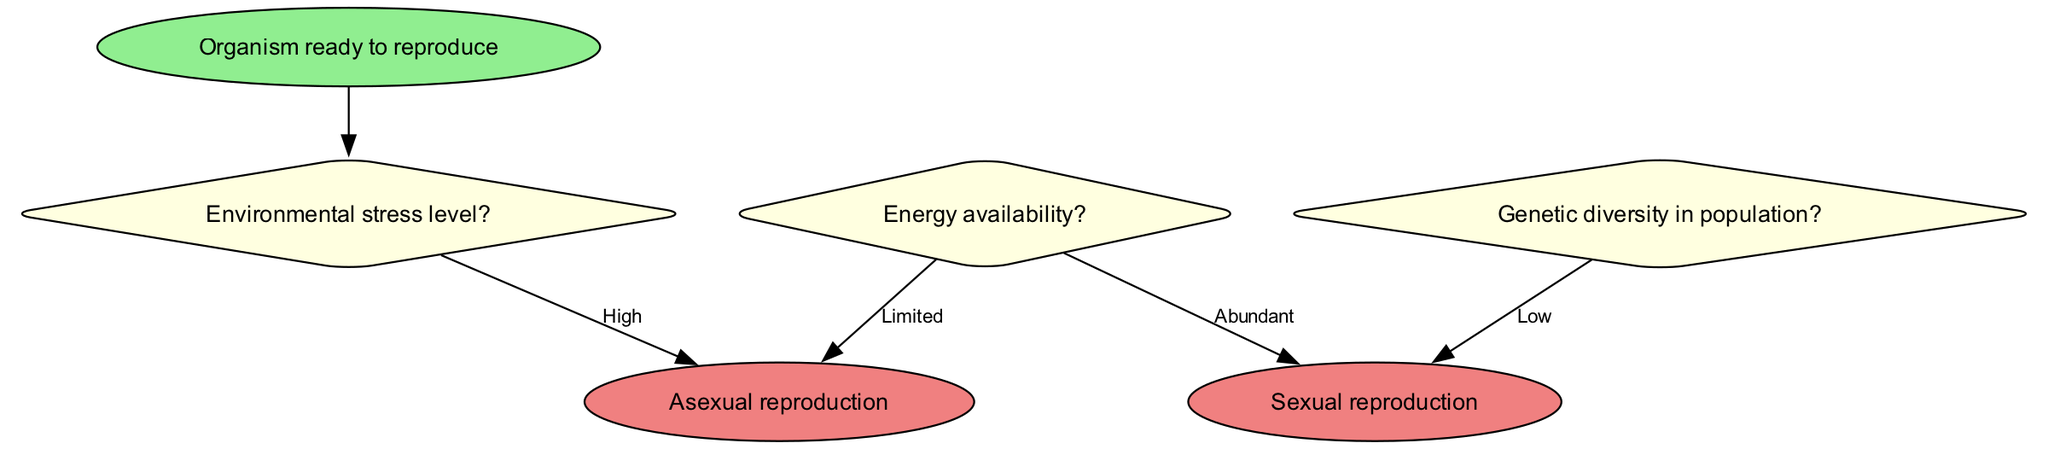What is the starting node in this flowchart? The flowchart starts with the node labeled "Organism ready to reproduce," which indicates the initial condition before any decisions are made.
Answer: Organism ready to reproduce How many decision nodes are present in the flowchart? There are three decision nodes labeled with questions regarding environmental stress, genetic diversity, and energy availability, indicating three distinct points of decision-making.
Answer: 3 What are the two reproductive strategies defined in the endpoints? The two endpoints specified in the flowchart are "Asexual reproduction" and "Sexual reproduction," which represent the outcomes based on the decision-making process.
Answer: Asexual reproduction, Sexual reproduction If the environmental stress level is low and genetic diversity is high, what is the next question to consider? Under the conditions of low environmental stress and high genetic diversity, the flowchart directs us to check the energy availability, indicating that this is the next step in the decision-making process.
Answer: Check energy availability What is the outcome if energy availability is limited? If energy availability is limited, the flowchart clearly indicates that the reproductive strategy will result in "Asexual reproduction," demonstrating the choice made based on the previous decision about energy.
Answer: Asexual reproduction What is the relationship between genetic diversity and the decision to reproduce sexually? The flowchart states that if genetic diversity in the population is high, the next step is to check energy availability; thus, high genetic diversity is a prerequisite for considering sexual reproduction, indicating that genetic diversity influences this decision.
Answer: Check energy availability What option follows if the environmental stress level is high? When the environmental stress level is high, the flowchart directs the organism to "Asexual reproduction," indicating a straightforward choice under stressful conditions without further decision-making.
Answer: Asexual reproduction What condition must be met for sexual reproduction to occur? For sexual reproduction to happen, both conditions of low environmental stress and high genetic diversity must be satisfied; if genetic diversity is low, sexual reproduction will not be chosen.
Answer: High genetic diversity 